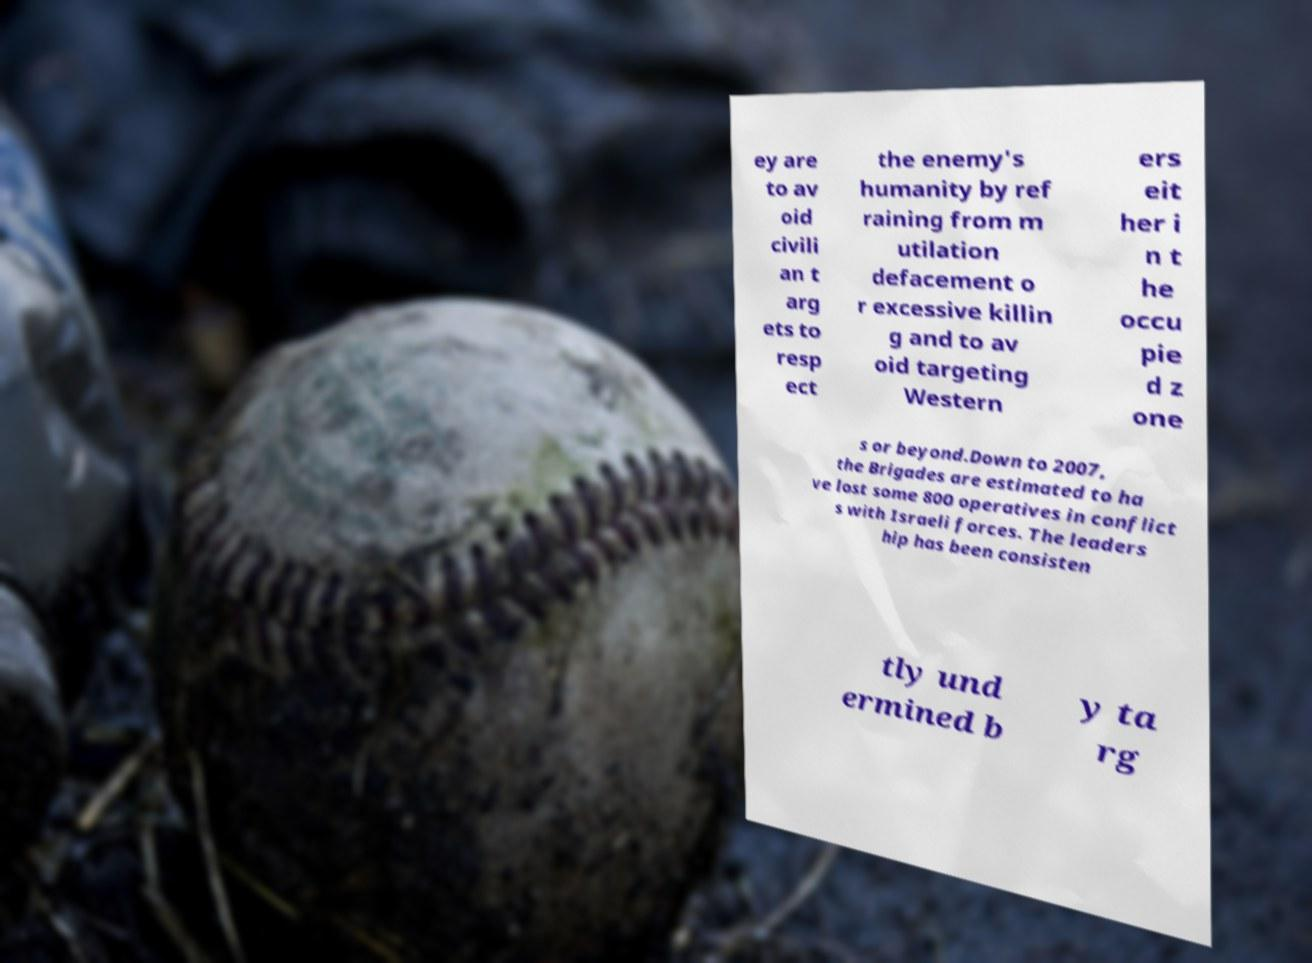Can you accurately transcribe the text from the provided image for me? ey are to av oid civili an t arg ets to resp ect the enemy's humanity by ref raining from m utilation defacement o r excessive killin g and to av oid targeting Western ers eit her i n t he occu pie d z one s or beyond.Down to 2007, the Brigades are estimated to ha ve lost some 800 operatives in conflict s with Israeli forces. The leaders hip has been consisten tly und ermined b y ta rg 